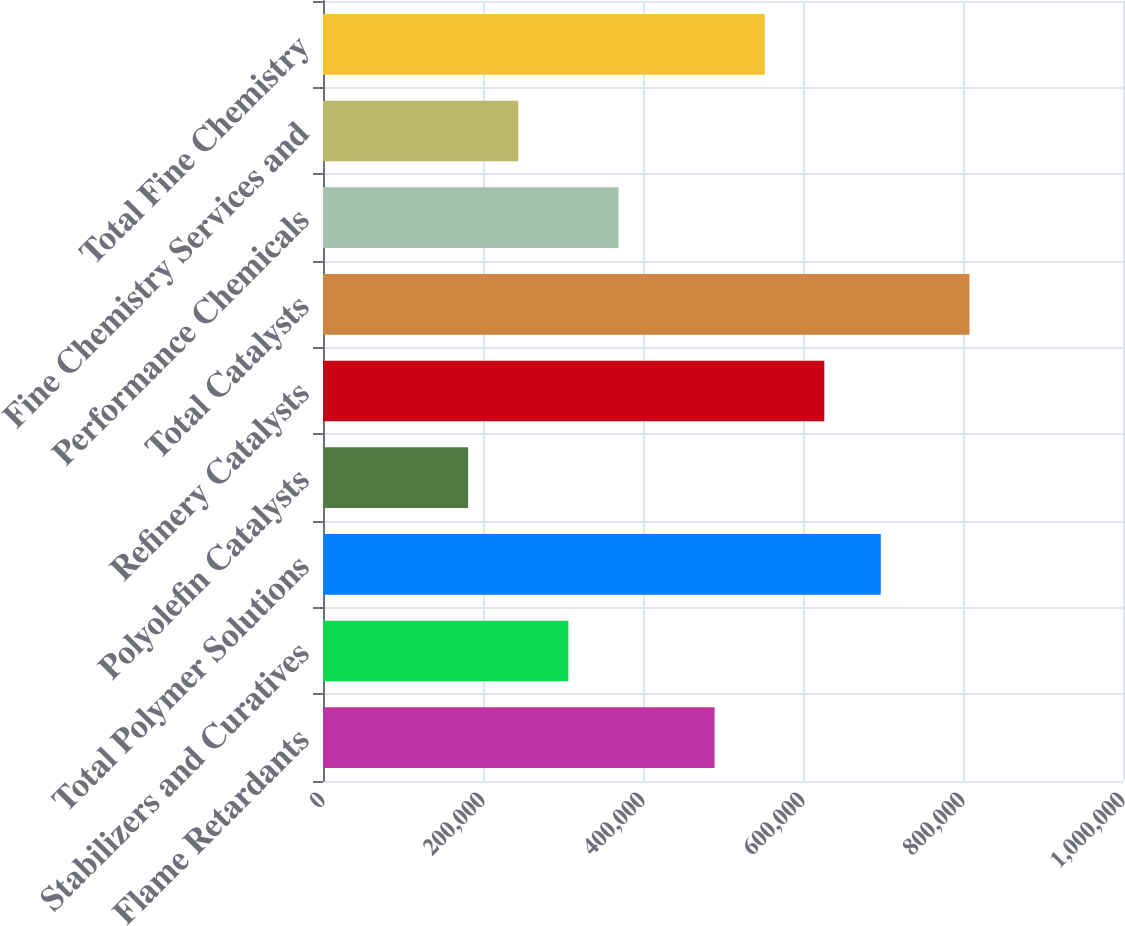Convert chart to OTSL. <chart><loc_0><loc_0><loc_500><loc_500><bar_chart><fcel>Flame Retardants<fcel>Stabilizers and Curatives<fcel>Total Polymer Solutions<fcel>Polyolefin Catalysts<fcel>Refinery Catalysts<fcel>Total Catalysts<fcel>Performance Chemicals<fcel>Fine Chemistry Services and<fcel>Total Fine Chemistry<nl><fcel>489484<fcel>306737<fcel>697206<fcel>181406<fcel>626657<fcel>808063<fcel>369403<fcel>244072<fcel>552150<nl></chart> 